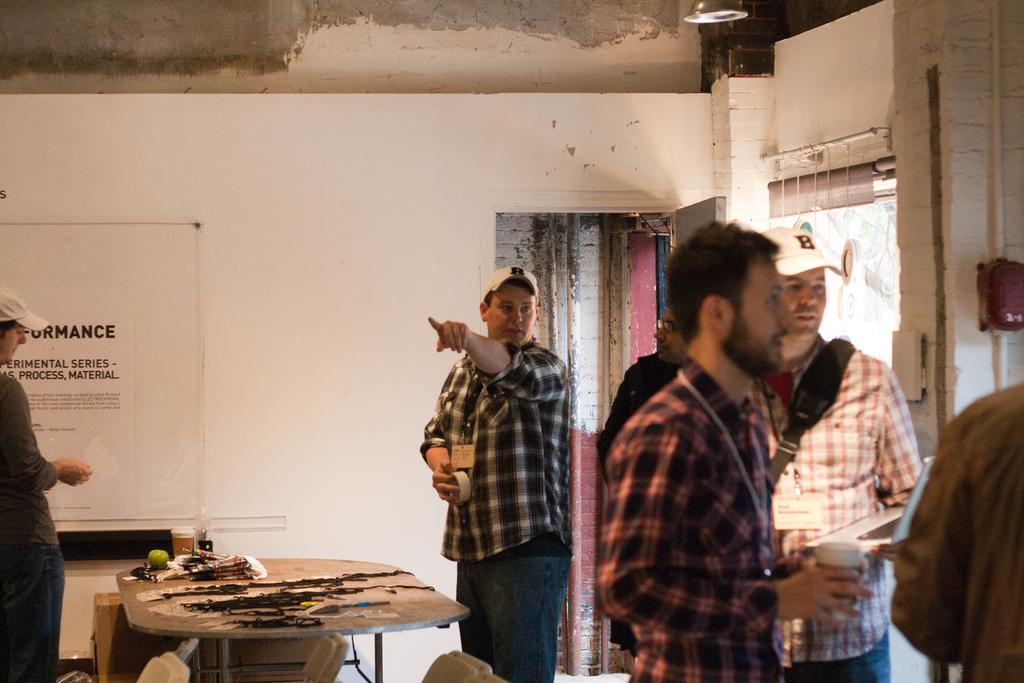What are the people in the image doing? The persons standing on the floor are likely engaged in some activity or standing near the table. What is the primary object in the foreground of the image? There is a table in the image. What can be seen in the background of the image? There is a wall and a board in the background of the image. What type of design can be seen on the bat in the image? There is no bat present in the image, so it is not possible to determine the design on a bat. 